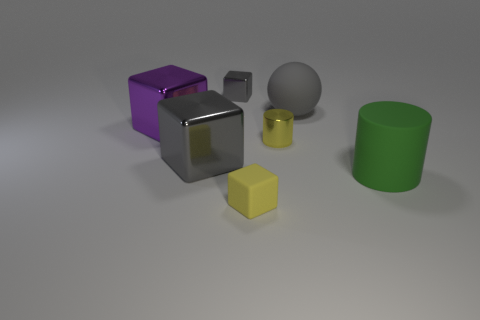Does the purple shiny object have the same size as the green rubber cylinder?
Make the answer very short. Yes. The tiny yellow thing that is the same material as the big ball is what shape?
Provide a short and direct response. Cube. How many other things are the same shape as the large purple thing?
Ensure brevity in your answer.  3. What shape is the small yellow thing that is behind the big matte thing in front of the big gray thing that is behind the metal cylinder?
Offer a very short reply. Cylinder. How many spheres are gray objects or yellow rubber things?
Your response must be concise. 1. Is there a ball that is in front of the yellow cylinder behind the yellow matte cube?
Provide a succinct answer. No. Are there any other things that have the same material as the small cylinder?
Make the answer very short. Yes. There is a yellow metal thing; is its shape the same as the gray metal thing that is behind the rubber sphere?
Provide a succinct answer. No. What number of other objects are there of the same size as the green rubber object?
Your answer should be very brief. 3. What number of green things are either big shiny objects or shiny cubes?
Give a very brief answer. 0. 